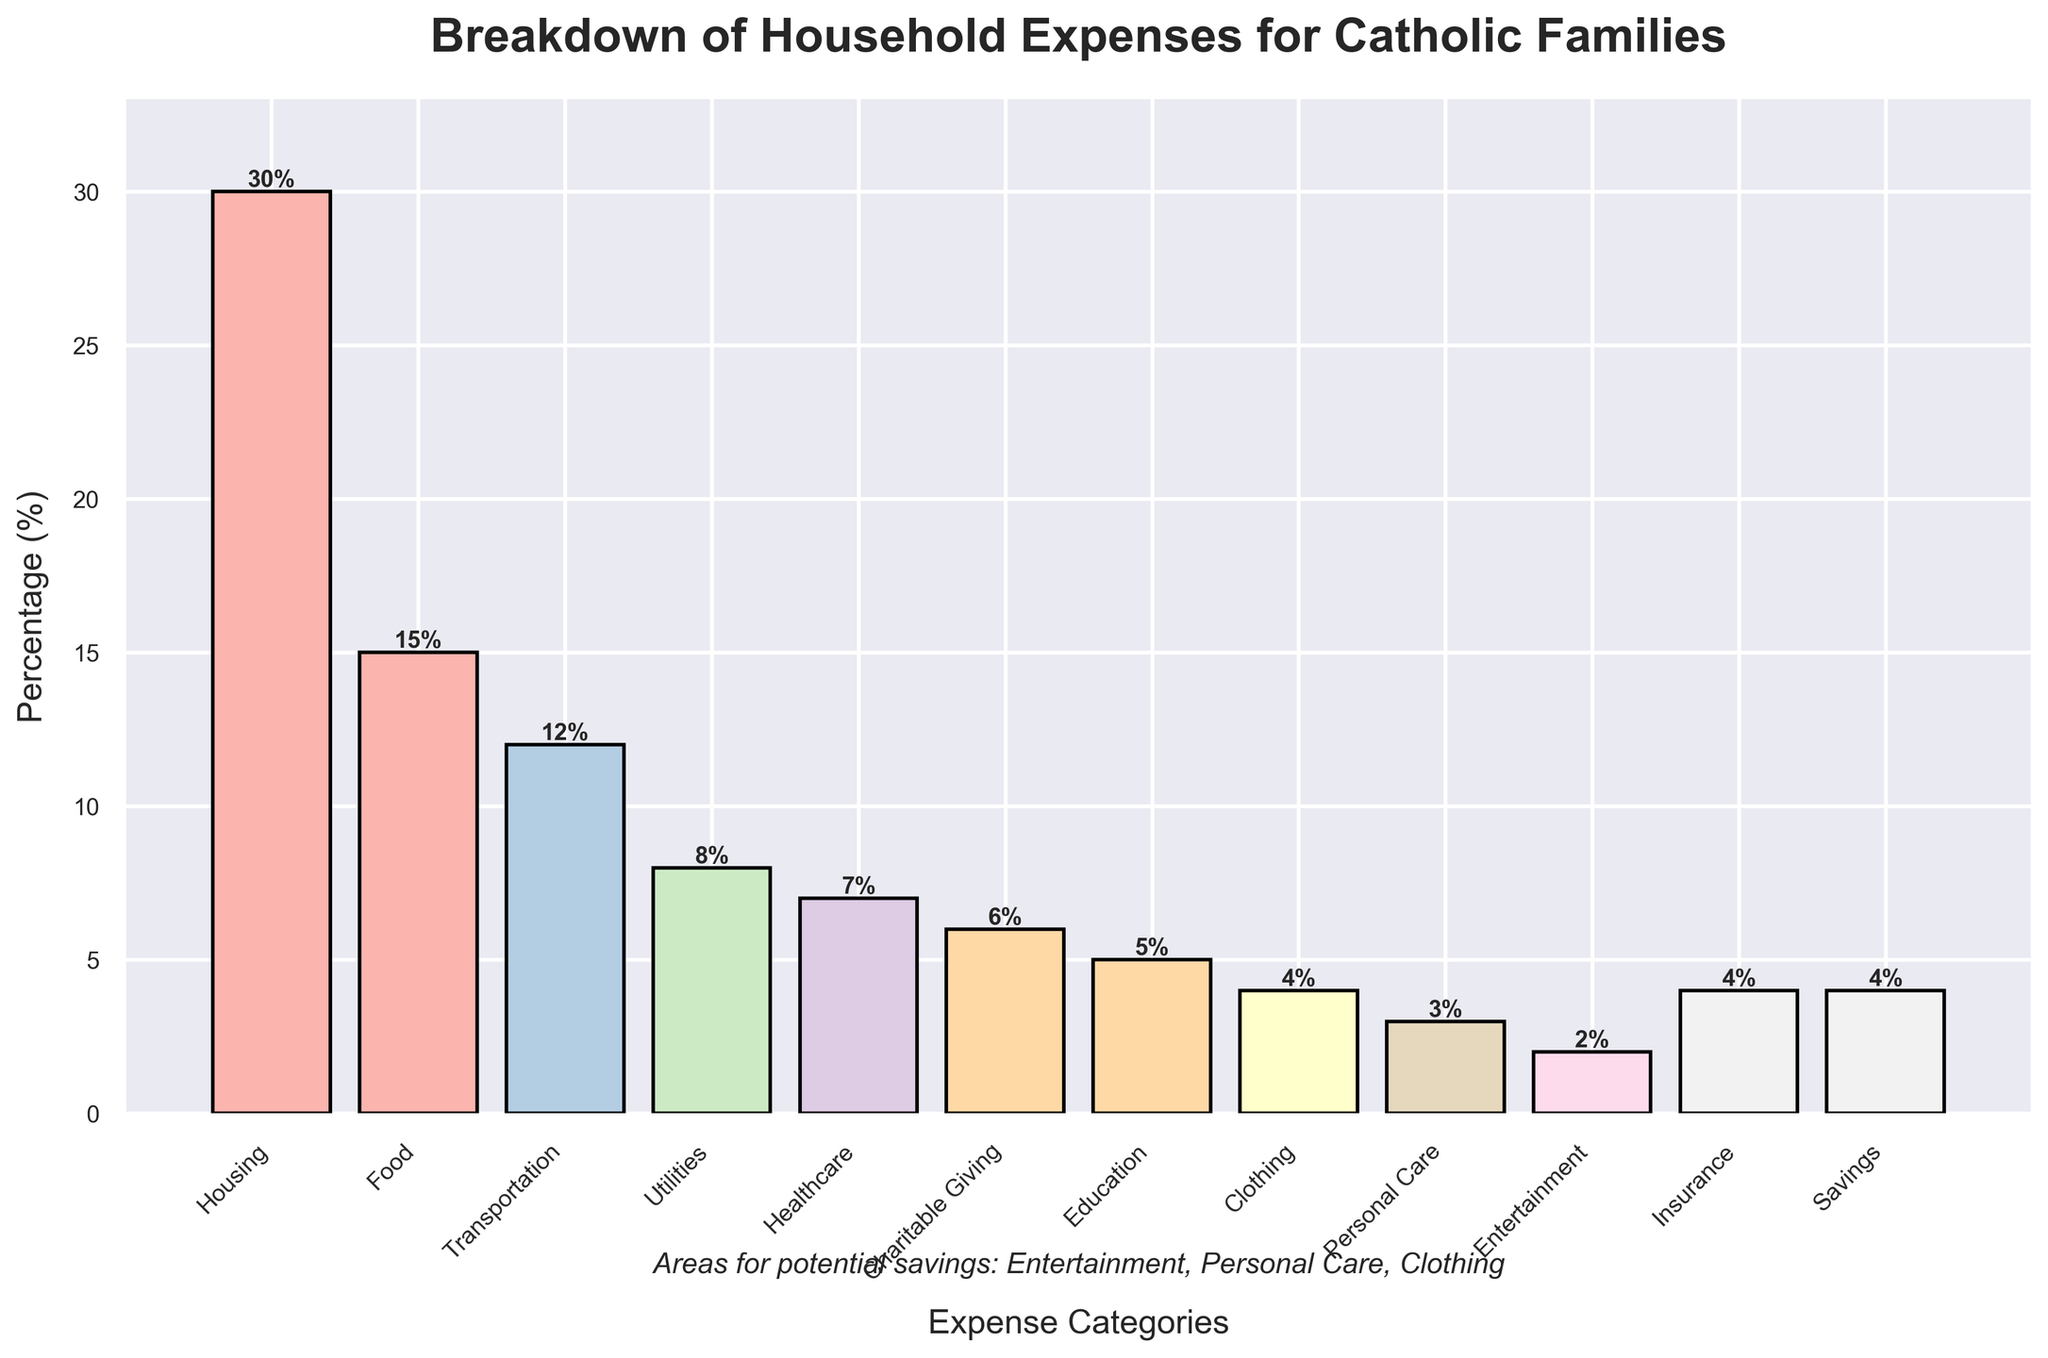what percentage of expenses is spent on basic necessities like Housing, Food, and Utilities? Adding the percentages for Housing (30%), Food (15%), and Utilities (8%) gives 30 + 15 + 8 = 53
Answer: 53% Which category has the lowest expenditure? By looking at the heights of the bars, the bar for Entertainment is the shortest, representing the lowest expenditure.
Answer: Entertainment How much more is spent on Transportation compared to Clothing? The percentage spent on Transportation is 12%, and on Clothing is 4%. The difference is 12 - 4 = 8
Answer: 8% What is the combined percentage of expenses for Charitable Giving and Education? Charitable Giving accounts for 6% and Education for 5%. Their combined percentage is 6 + 5 = 11
Answer: 11% Are the percentages for Insurance and Savings equal? Both the Insurance and Savings categories have percentages of 4%.
Answer: Yes Which has a higher expenditure: Healthcare or Personal Care? The bar for Healthcare is taller than the bar for Personal Care, with percentages of 7% and 3%, respectively.
Answer: Healthcare What is the average percentage of expenses for Housing and Utilities? The percentages for Housing and Utilities are 30% and 8%. Their average is (30 + 8) / 2 = 19
Answer: 19 Is the expenditure on Entertainment less than 5%? The percentage for Entertainment is 2%, which is less than 5%.
Answer: Yes How many categories have an expenditure percentage less than 10%? The categories with less than 10% are Food (15%), Transportation (12%), and Housing (30%). Nine categories have less than 10%.
Answer: 9 Which categories are highlighted as areas for potential savings? Below the bar chart, it mentions Entertainment, Personal Care, and Clothing as areas for potential savings.
Answer: Entertainment, Personal Care, Clothing 